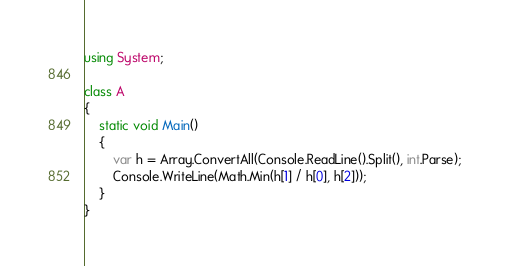<code> <loc_0><loc_0><loc_500><loc_500><_C#_>using System;

class A
{
	static void Main()
	{
		var h = Array.ConvertAll(Console.ReadLine().Split(), int.Parse);
		Console.WriteLine(Math.Min(h[1] / h[0], h[2]));
	}
}
</code> 